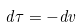<formula> <loc_0><loc_0><loc_500><loc_500>d \tau = - d v</formula> 